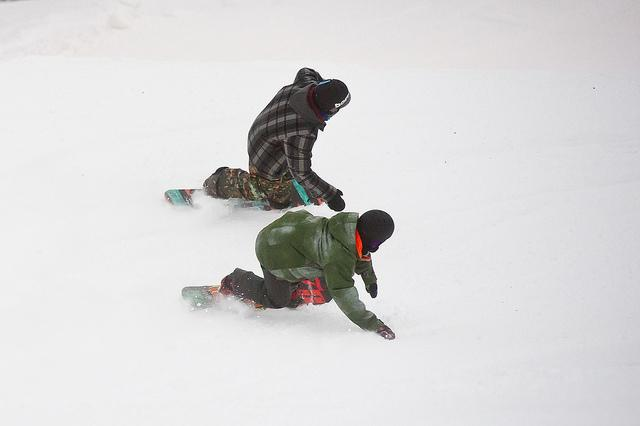What is the person on the right's hand touching? snow 